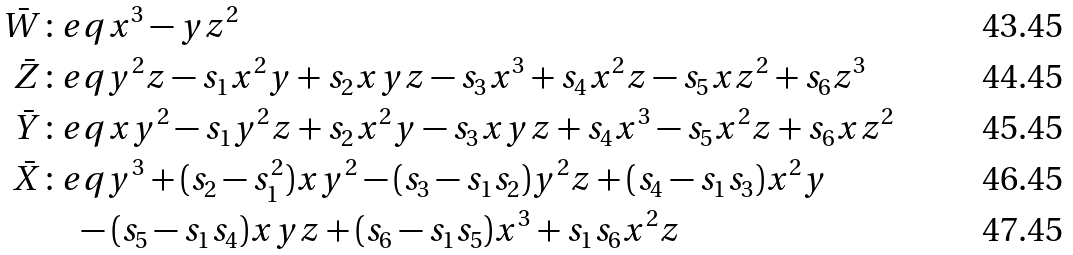Convert formula to latex. <formula><loc_0><loc_0><loc_500><loc_500>\bar { W } & \colon e q x ^ { 3 } - y z ^ { 2 } \\ \bar { Z } & \colon e q y ^ { 2 } z - s _ { 1 } x ^ { 2 } y + s _ { 2 } x y z - s _ { 3 } x ^ { 3 } + s _ { 4 } x ^ { 2 } z - s _ { 5 } x z ^ { 2 } + s _ { 6 } z ^ { 3 } \\ \bar { Y } & \colon e q x y ^ { 2 } - s _ { 1 } y ^ { 2 } z + s _ { 2 } x ^ { 2 } y - s _ { 3 } x y z + s _ { 4 } x ^ { 3 } - s _ { 5 } x ^ { 2 } z + s _ { 6 } x z ^ { 2 } \\ \bar { X } & \colon e q y ^ { 3 } + ( s _ { 2 } - s _ { 1 } ^ { 2 } ) x y ^ { 2 } - ( s _ { 3 } - s _ { 1 } s _ { 2 } ) y ^ { 2 } z + ( s _ { 4 } - s _ { 1 } s _ { 3 } ) x ^ { 2 } y \\ & \quad - ( s _ { 5 } - s _ { 1 } s _ { 4 } ) x y z + ( s _ { 6 } - s _ { 1 } s _ { 5 } ) x ^ { 3 } + s _ { 1 } s _ { 6 } x ^ { 2 } z</formula> 